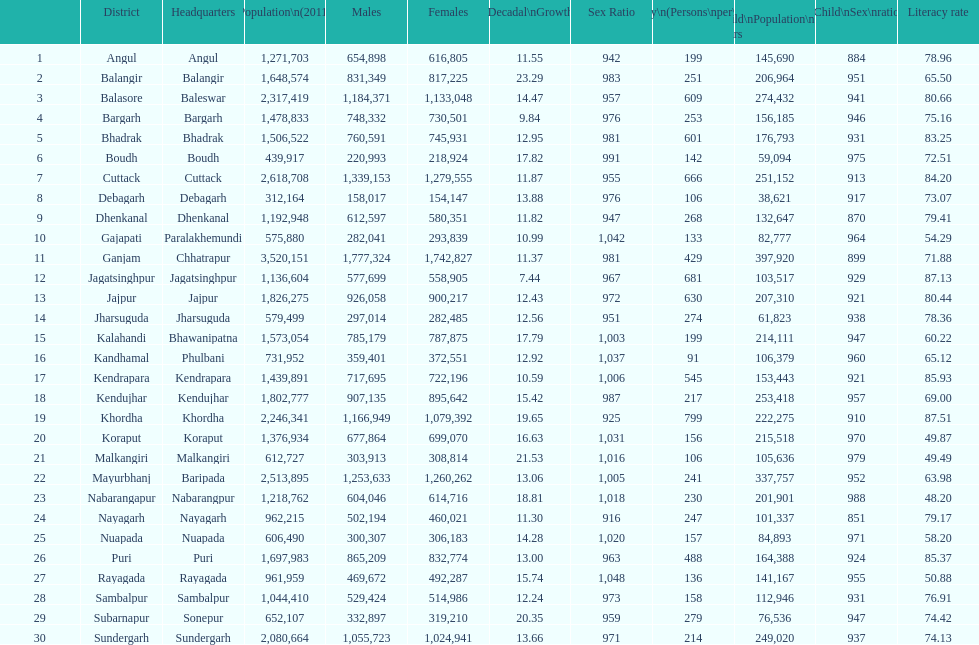In which city is the literacy rate the lowest? Nabarangapur. 